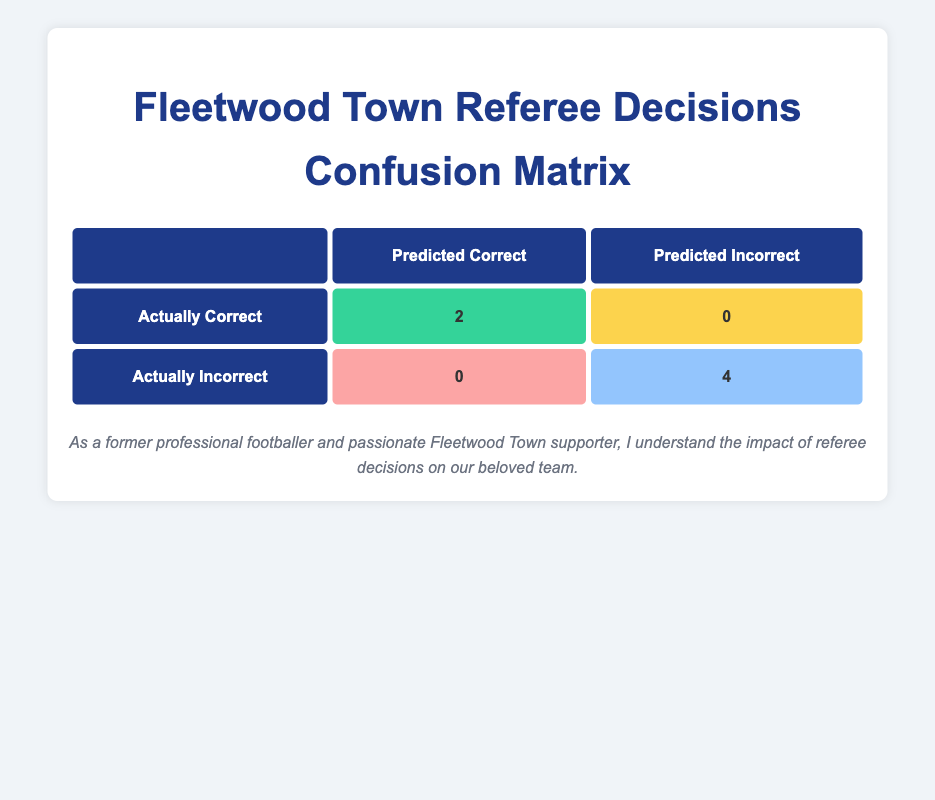What is the total number of referee decisions that were incorrect for Fleetwood Town? There are 4 instances of incorrect decisions listed in the table: "Incorrect Offside Call" (2 times), "Penalty Awarded Incorrectly," and "Incorrect Red Card." Counting these gives us a total of 4 incorrect decisions.
Answer: 4 How many referee decisions were actually correct for Fleetwood Town? The table shows that there are 2 instances of correct decisions: "Correct Goal Allowed" (2 times). Thus, the total number of correct decisions is 2.
Answer: 2 What percentage of decisions were correct overall? There were a total of 6 decisions (2 correct and 4 incorrect). To find the percentage of correct decisions: (2/6) * 100 = 33.33%. Therefore, 33% of the decisions were correct.
Answer: 33% Is it true that all incorrect decisions were made against Fleetwood Town? All the entries in the table involve Fleetwood Town, showing all incorrect decisions relate to this team. Hence, it is true that all incorrect decisions were against Fleetwood Town.
Answer: Yes How many more incorrect decisions were made compared to correct ones? There are 4 incorrect decisions and 2 correct decisions. Subtracting the number of correct decisions from the incorrect ones gives us 4 - 2 = 2. Therefore, there were 2 more incorrect decisions.
Answer: 2 List the types of decisions that were made correctly. The table indicates that the decisions that were made correctly are "Correct Goal Allowed," which happened in two matches. All correct decisions involve allowing goals, with no other types present.
Answer: Correct Goal Allowed What percentage of incorrect decisions resulted from offside calls? The incorrect decisions include 2 instances of "Incorrect Offside Call" out of 4 total incorrect decisions. To find the percentage: (2/4) * 100 = 50%. Therefore, 50% of incorrect decisions were offside calls.
Answer: 50% What is the minute when the latest incorrect decision occurred? The incorrect decisions occurred at minutes 34, 75, 18, and 89. Among these, the highest minute is 89, which corresponds to the last incorrect decision.
Answer: 89 